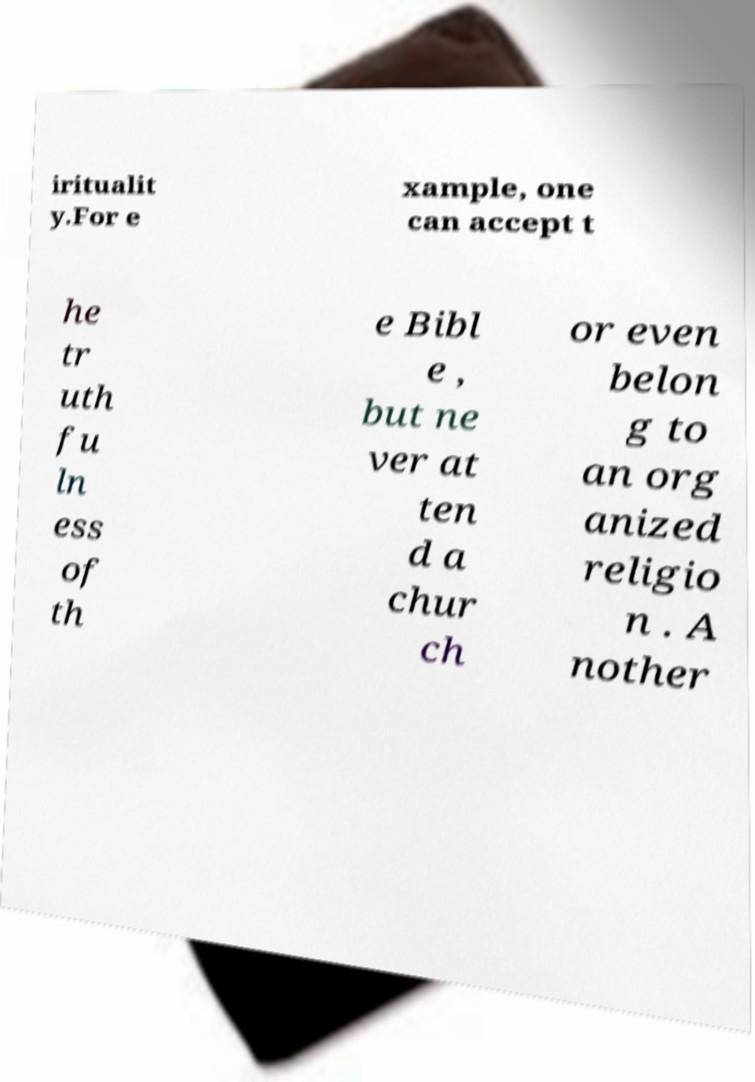Could you extract and type out the text from this image? iritualit y.For e xample, one can accept t he tr uth fu ln ess of th e Bibl e , but ne ver at ten d a chur ch or even belon g to an org anized religio n . A nother 